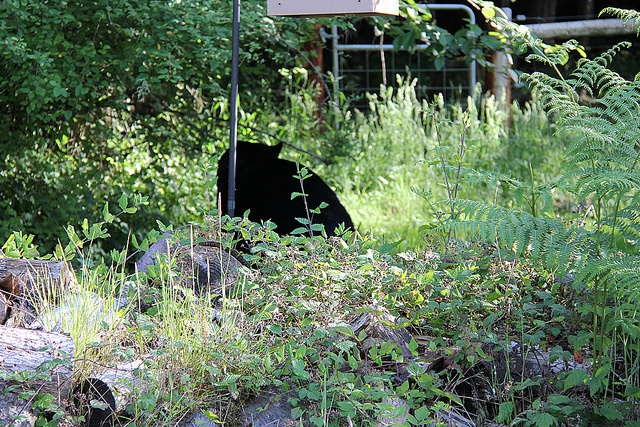Describe the objects in this image and their specific colors. I can see a bear in darkgreen, black, darkblue, gray, and green tones in this image. 